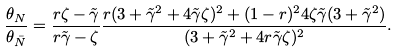<formula> <loc_0><loc_0><loc_500><loc_500>\frac { \theta _ { N } } { \theta _ { \bar { N } } } = \frac { r \zeta - \tilde { \gamma } } { r \tilde { \gamma } - \zeta } \frac { r ( 3 + \tilde { \gamma } ^ { 2 } + 4 \tilde { \gamma } \zeta ) ^ { 2 } + ( 1 - r ) ^ { 2 } 4 \zeta \tilde { \gamma } ( 3 + \tilde { \gamma } ^ { 2 } ) } { ( 3 + \tilde { \gamma } ^ { 2 } + 4 r \tilde { \gamma } \zeta ) ^ { 2 } } .</formula> 